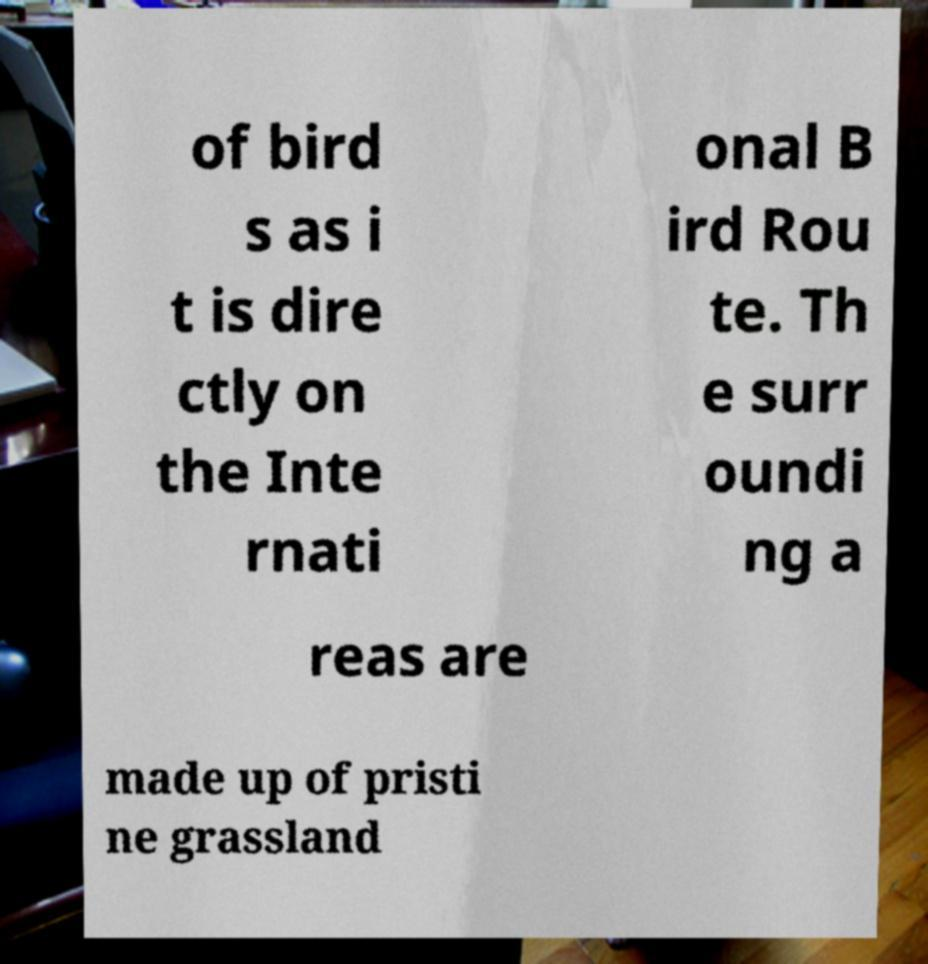Can you accurately transcribe the text from the provided image for me? of bird s as i t is dire ctly on the Inte rnati onal B ird Rou te. Th e surr oundi ng a reas are made up of pristi ne grassland 